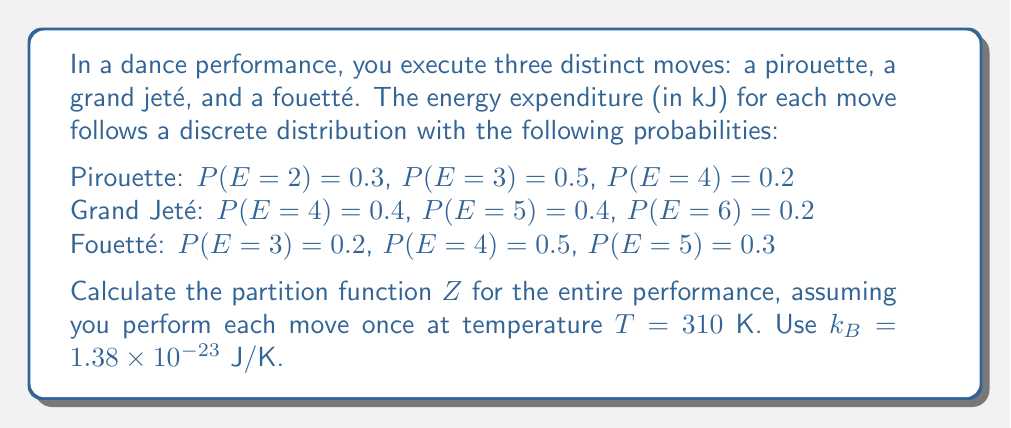Give your solution to this math problem. To solve this problem, we need to follow these steps:

1) The partition function $Z$ for a system with discrete energy levels is given by:

   $$Z = \sum_i g_i e^{-E_i/k_BT}$$

   where $g_i$ is the degeneracy (or probability) of each energy level $E_i$.

2) For each move, we need to calculate its individual partition function:

   For Pirouette:
   $$Z_p = 0.3e^{-2000/(1.38 \times 10^{-23} \times 310)} + 0.5e^{-3000/(1.38 \times 10^{-23} \times 310)} + 0.2e^{-4000/(1.38 \times 10^{-23} \times 310)}$$

   For Grand Jeté:
   $$Z_g = 0.4e^{-4000/(1.38 \times 10^{-23} \times 310)} + 0.4e^{-5000/(1.38 \times 10^{-23} \times 310)} + 0.2e^{-6000/(1.38 \times 10^{-23} \times 310)}$$

   For Fouetté:
   $$Z_f = 0.2e^{-3000/(1.38 \times 10^{-23} \times 310)} + 0.5e^{-4000/(1.38 \times 10^{-23} \times 310)} + 0.3e^{-5000/(1.38 \times 10^{-23} \times 310)}$$

3) Simplify the exponents:
   $1/(1.38 \times 10^{-23} \times 310) = 2.33 \times 10^{20}$

4) Calculate each partition function:
   $$Z_p = 0.3e^{-4.66 \times 10^{17}} + 0.5e^{-6.99 \times 10^{17}} + 0.2e^{-9.32 \times 10^{17}} \approx 0.3$$
   $$Z_g = 0.4e^{-9.32 \times 10^{17}} + 0.4e^{-11.65 \times 10^{17}} + 0.2e^{-13.98 \times 10^{17}} \approx 0.4$$
   $$Z_f = 0.2e^{-6.99 \times 10^{17}} + 0.5e^{-9.32 \times 10^{17}} + 0.3e^{-11.65 \times 10^{17}} \approx 0.2$$

5) The total partition function for the performance is the product of individual partition functions:

   $$Z = Z_p \times Z_g \times Z_f = 0.3 \times 0.4 \times 0.2 = 0.024$$
Answer: $0.024$ 